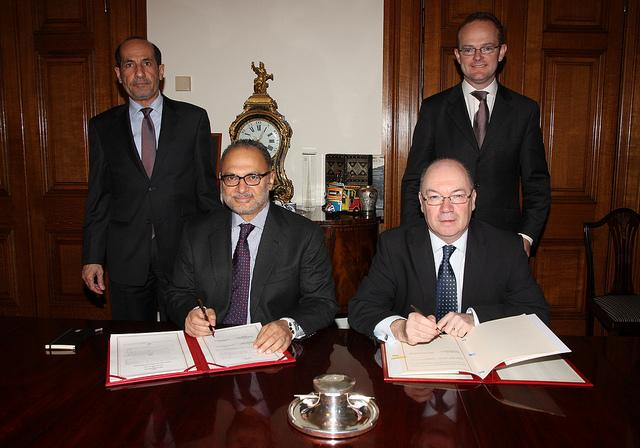What type of event is this? signing 